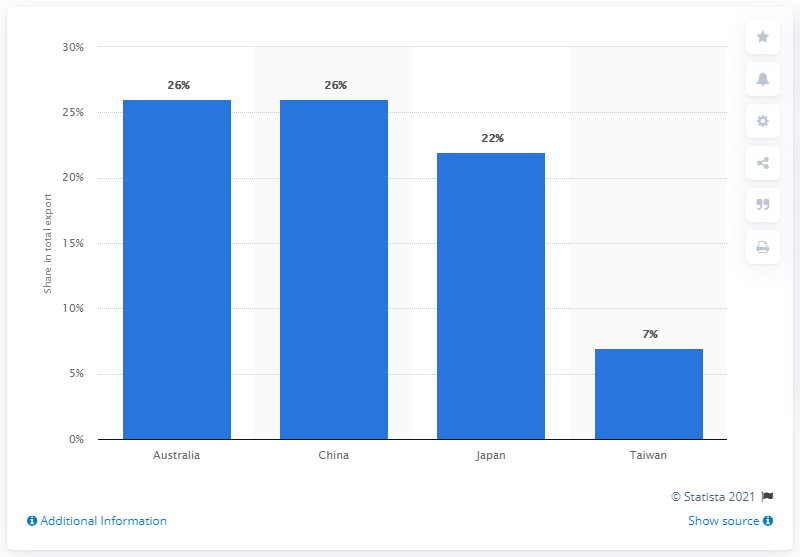List a handful of essential elements in this visual. In 2019, Papua New Guinea's main export partner was Australia. 